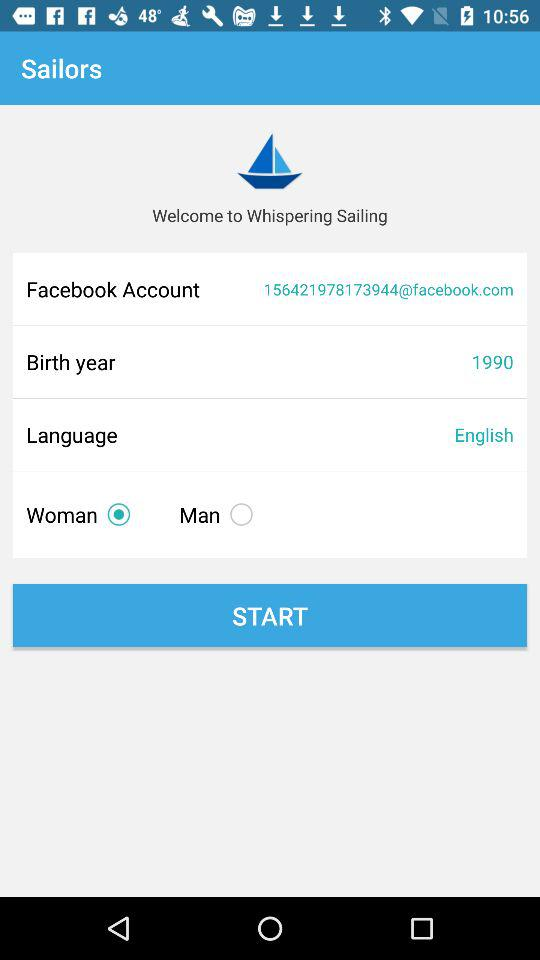What is the name of the application? The name of the application is "Whispering Sailors". 